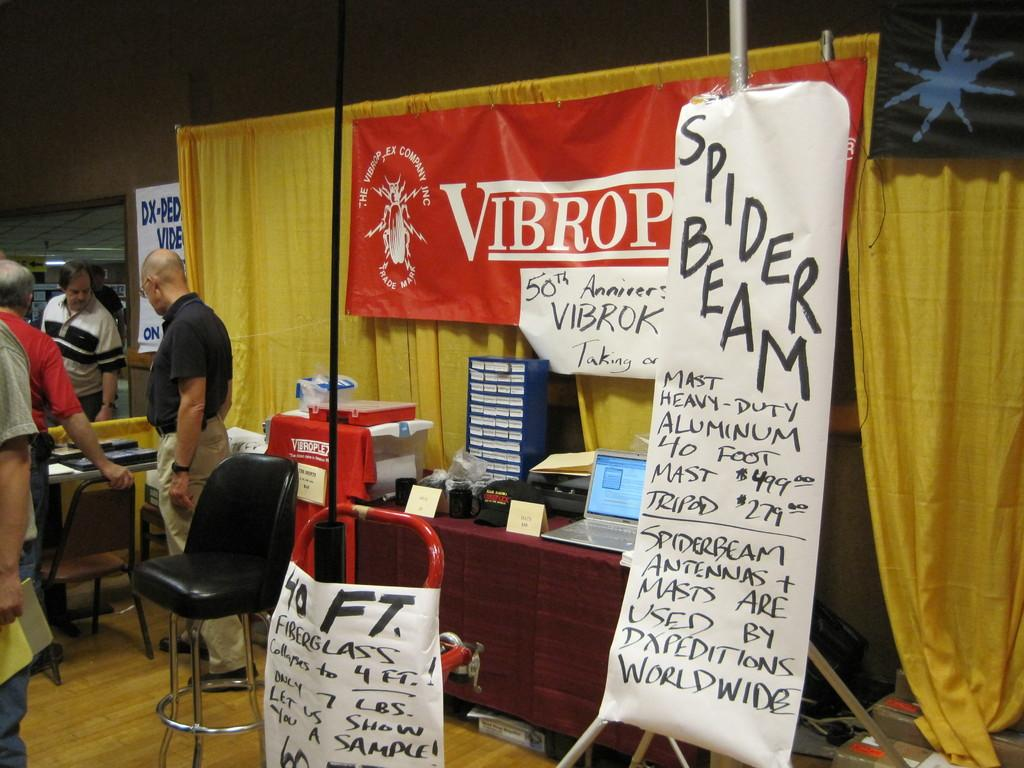What is hanging in the image? There is a banner in the image. What type of furniture is present in the image? There is a chair in the image. What electronic device can be seen in the image? There is a laptop in the image. What type of window treatment is visible in the image? There are curtains in the image. What surface are the persons standing on in the image? The persons are standing on the floor in the image. What is the taste of the chair in the image? Chairs do not have a taste; they are objects made of materials like wood or plastic. What is the tendency of the banner in the image? The banner in the image is stationary and does not exhibit any tendency. 